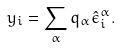<formula> <loc_0><loc_0><loc_500><loc_500>y _ { i } = \sum _ { \alpha } q _ { \alpha } \hat { \epsilon } _ { i } ^ { \alpha } .</formula> 